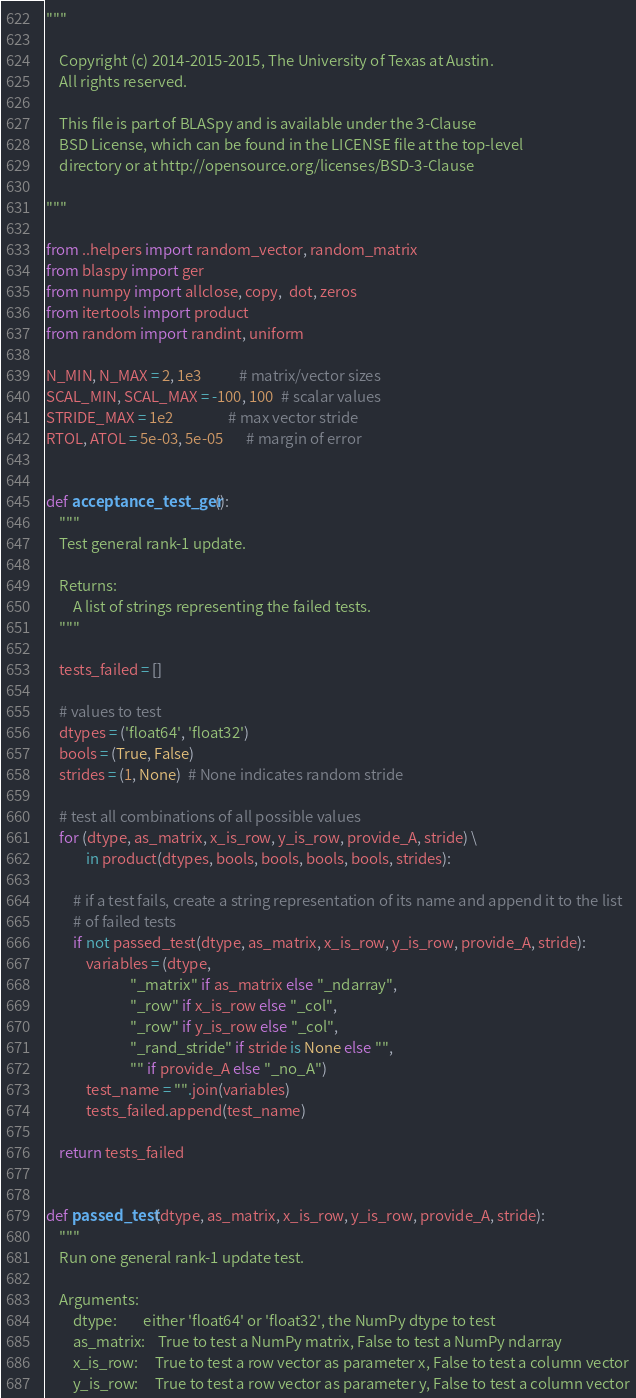<code> <loc_0><loc_0><loc_500><loc_500><_Python_>"""

    Copyright (c) 2014-2015-2015, The University of Texas at Austin.
    All rights reserved.

    This file is part of BLASpy and is available under the 3-Clause
    BSD License, which can be found in the LICENSE file at the top-level
    directory or at http://opensource.org/licenses/BSD-3-Clause

"""

from ..helpers import random_vector, random_matrix
from blaspy import ger
from numpy import allclose, copy,  dot, zeros
from itertools import product
from random import randint, uniform

N_MIN, N_MAX = 2, 1e3           # matrix/vector sizes
SCAL_MIN, SCAL_MAX = -100, 100  # scalar values
STRIDE_MAX = 1e2                # max vector stride
RTOL, ATOL = 5e-03, 5e-05       # margin of error


def acceptance_test_ger():
    """
    Test general rank-1 update.

    Returns:
        A list of strings representing the failed tests.
    """

    tests_failed = []

    # values to test
    dtypes = ('float64', 'float32')
    bools = (True, False)
    strides = (1, None)  # None indicates random stride

    # test all combinations of all possible values
    for (dtype, as_matrix, x_is_row, y_is_row, provide_A, stride) \
            in product(dtypes, bools, bools, bools, bools, strides):

        # if a test fails, create a string representation of its name and append it to the list
        # of failed tests
        if not passed_test(dtype, as_matrix, x_is_row, y_is_row, provide_A, stride):
            variables = (dtype,
                         "_matrix" if as_matrix else "_ndarray",
                         "_row" if x_is_row else "_col",
                         "_row" if y_is_row else "_col",
                         "_rand_stride" if stride is None else "",
                         "" if provide_A else "_no_A")
            test_name = "".join(variables)
            tests_failed.append(test_name)

    return tests_failed


def passed_test(dtype, as_matrix, x_is_row, y_is_row, provide_A, stride):
    """
    Run one general rank-1 update test.

    Arguments:
        dtype:        either 'float64' or 'float32', the NumPy dtype to test
        as_matrix:    True to test a NumPy matrix, False to test a NumPy ndarray
        x_is_row:     True to test a row vector as parameter x, False to test a column vector
        y_is_row:     True to test a row vector as parameter y, False to test a column vector</code> 